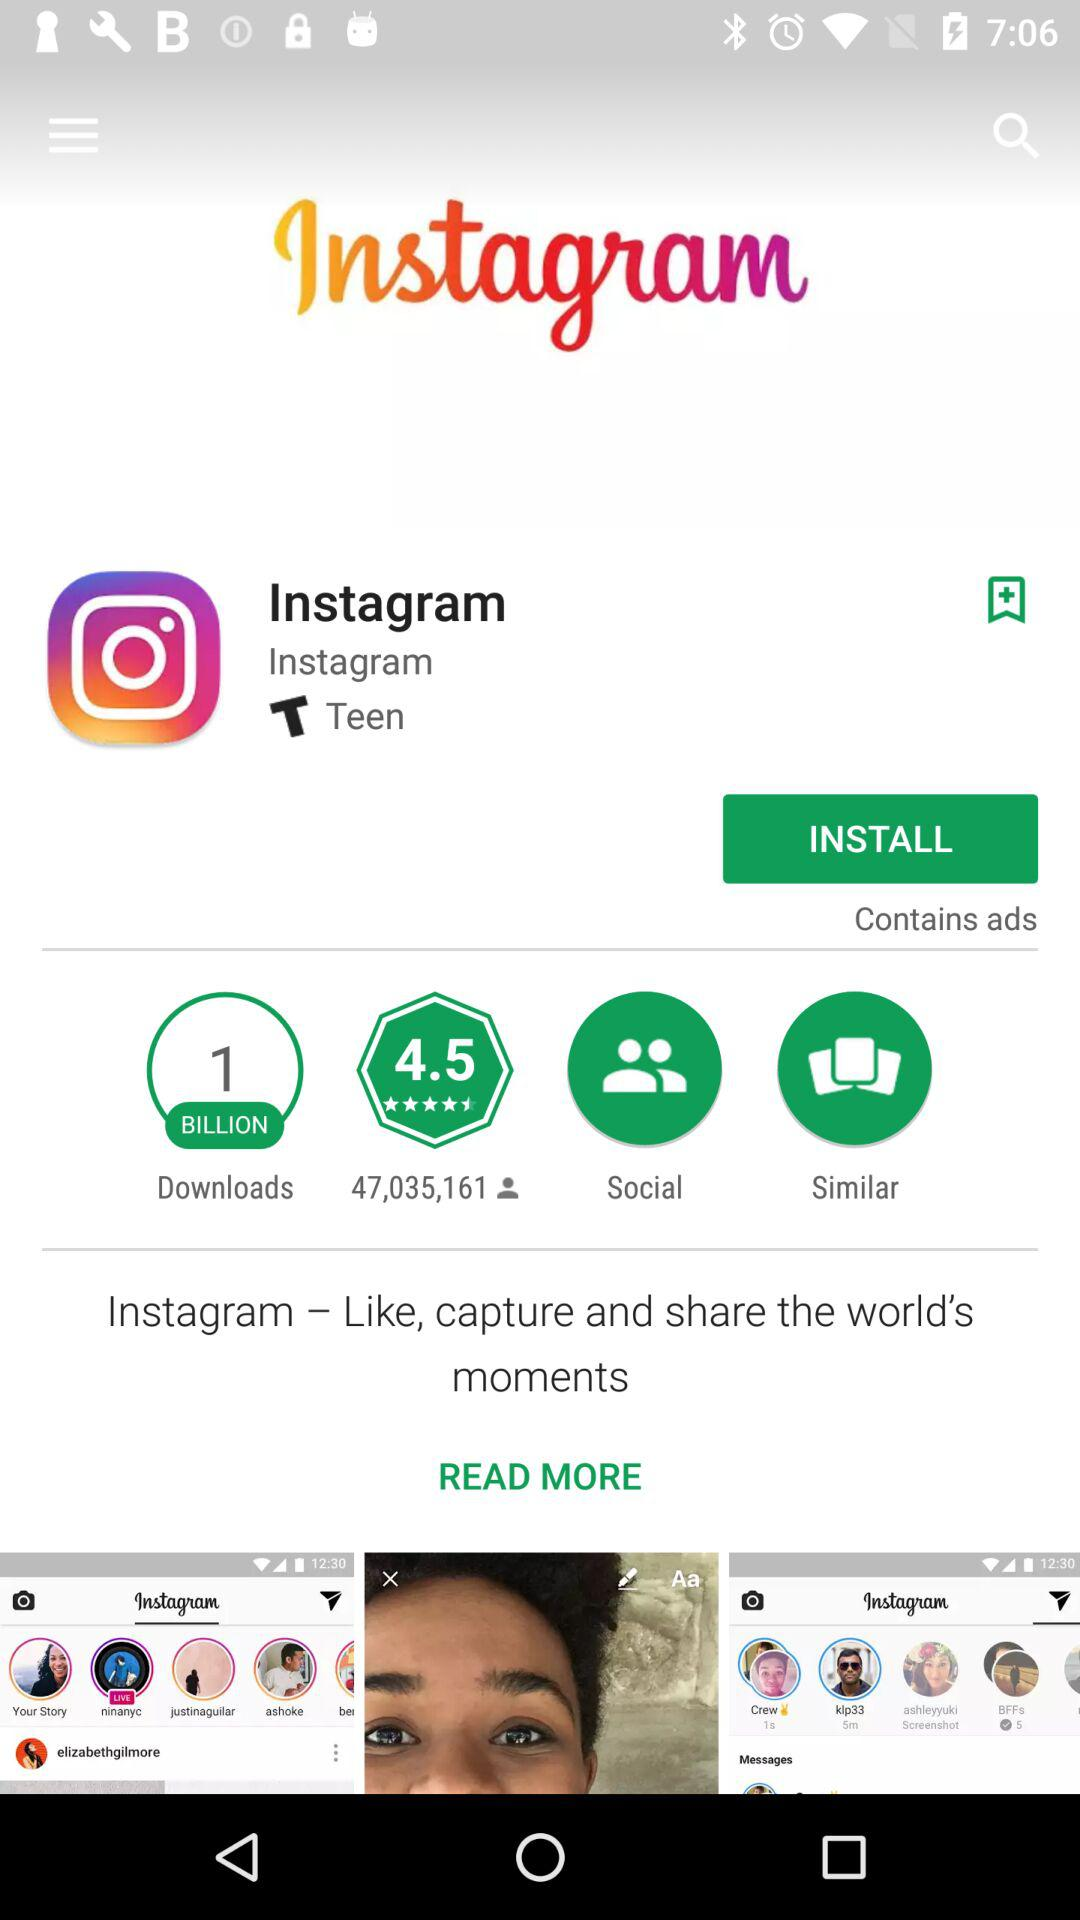How many people downloaded the application? There were 1 billion people who downloaded the application. 